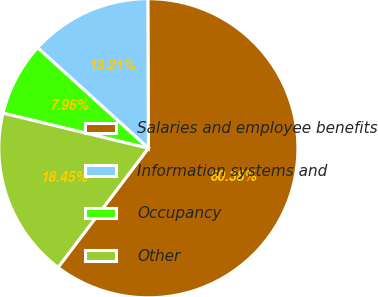Convert chart. <chart><loc_0><loc_0><loc_500><loc_500><pie_chart><fcel>Salaries and employee benefits<fcel>Information systems and<fcel>Occupancy<fcel>Other<nl><fcel>60.38%<fcel>13.21%<fcel>7.96%<fcel>18.45%<nl></chart> 